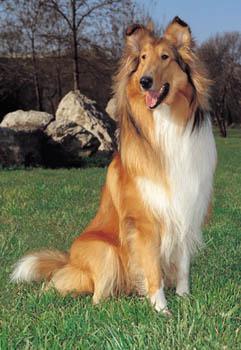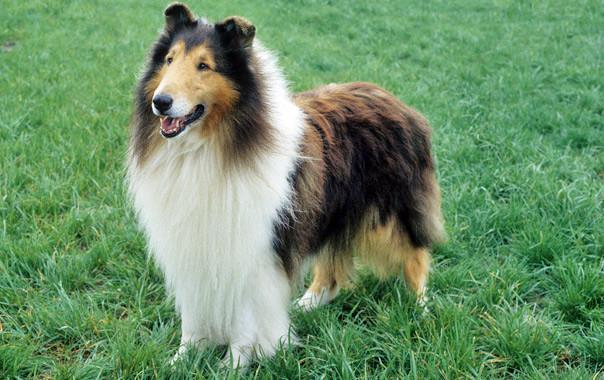The first image is the image on the left, the second image is the image on the right. For the images displayed, is the sentence "The dog in the image on the right is moving toward the camera" factually correct? Answer yes or no. No. 